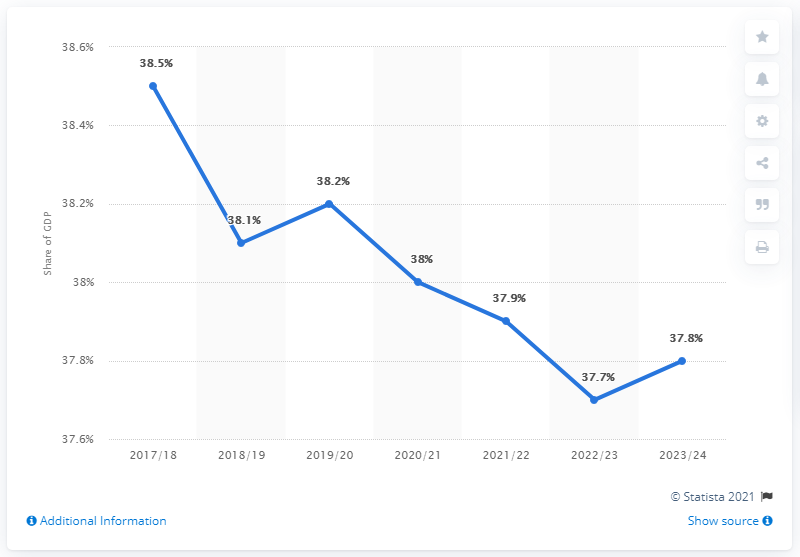Mention a couple of crucial points in this snapshot. In 2017/18, the government expenditure of the United Kingdom was approximately 39.4% of its Gross Domestic Product. 